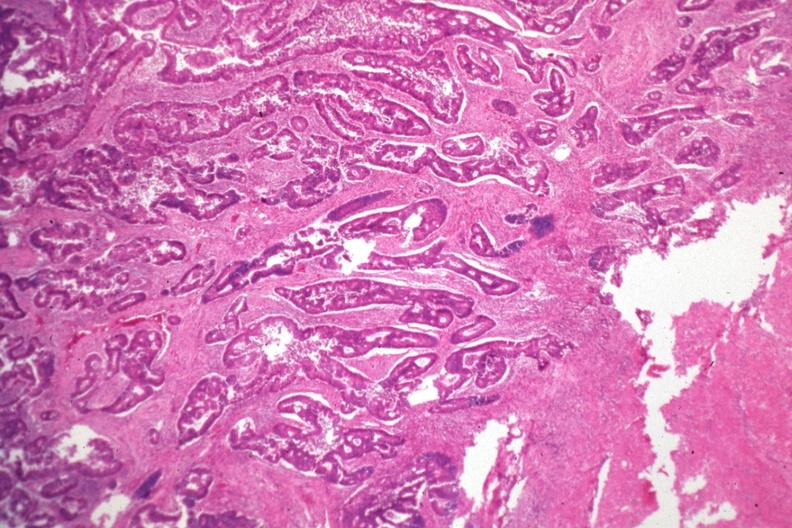s adrenal present?
Answer the question using a single word or phrase. No 